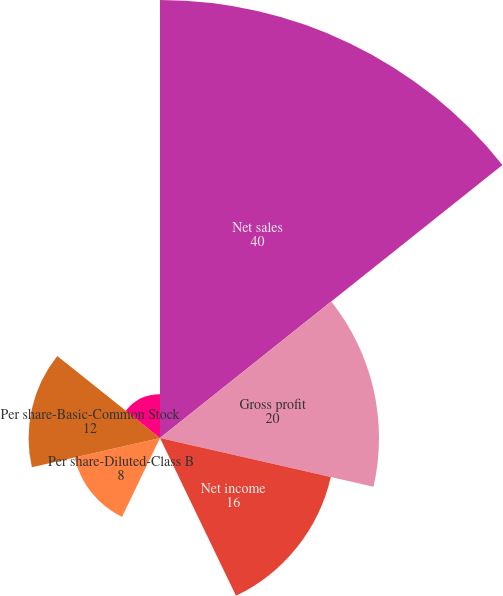Convert chart to OTSL. <chart><loc_0><loc_0><loc_500><loc_500><pie_chart><fcel>Net sales<fcel>Gross profit<fcel>Net income<fcel>Per share-Basic-Class B Common<fcel>Per share-Diluted-Class B<fcel>Per share-Basic-Common Stock<fcel>Per share-Diluted-Common Stock<nl><fcel>40.0%<fcel>20.0%<fcel>16.0%<fcel>0.0%<fcel>8.0%<fcel>12.0%<fcel>4.0%<nl></chart> 